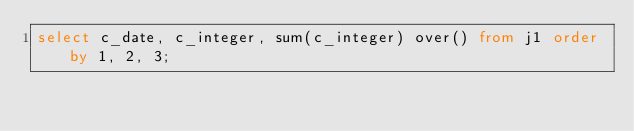<code> <loc_0><loc_0><loc_500><loc_500><_SQL_>select c_date, c_integer, sum(c_integer) over() from j1 order by 1, 2, 3;
</code> 